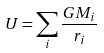Convert formula to latex. <formula><loc_0><loc_0><loc_500><loc_500>U = \sum _ { i } \frac { G M _ { i } } { r _ { i } }</formula> 